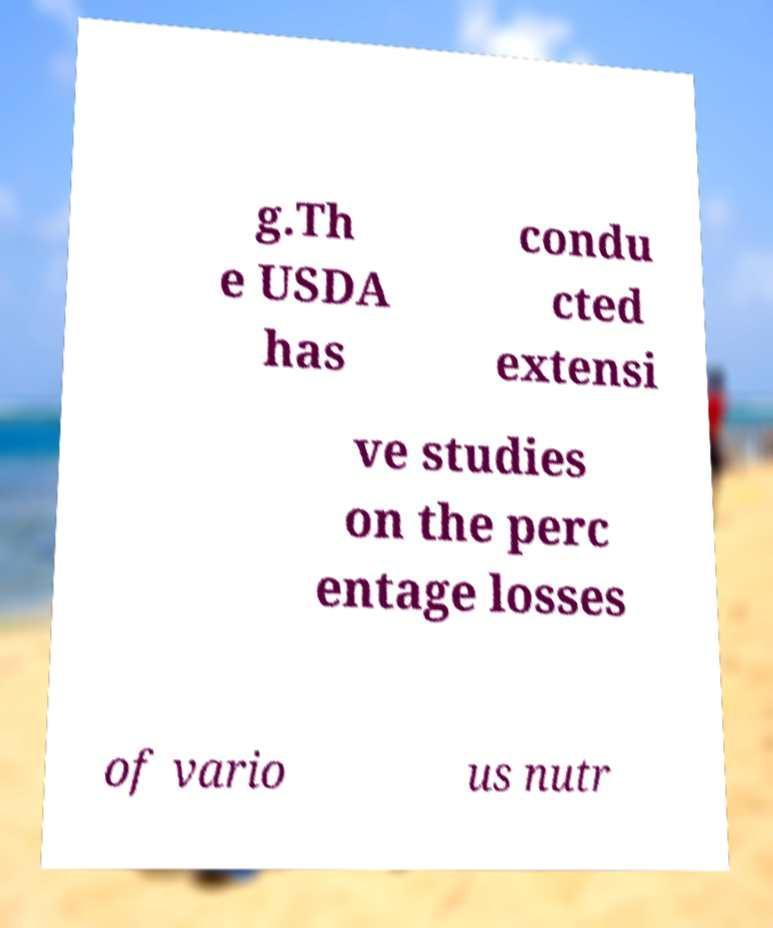Could you assist in decoding the text presented in this image and type it out clearly? g.Th e USDA has condu cted extensi ve studies on the perc entage losses of vario us nutr 